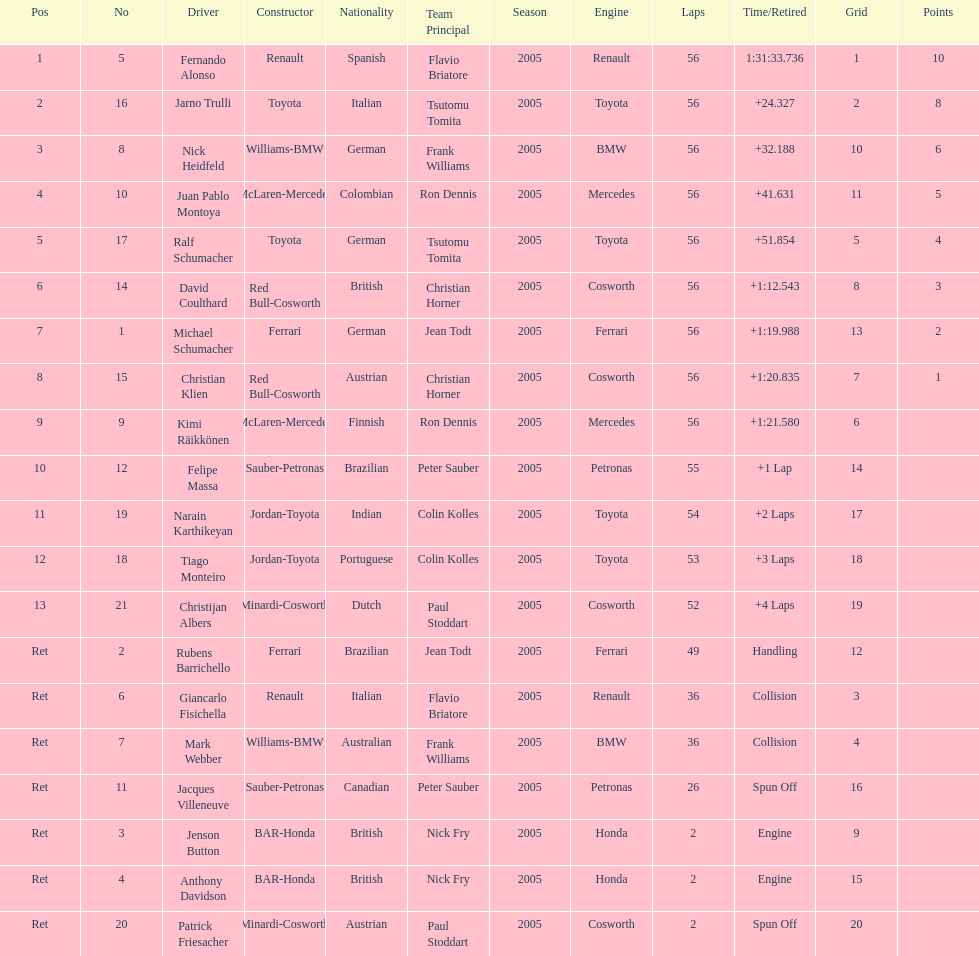Who was the last driver from the uk to actually finish the 56 laps? David Coulthard. 